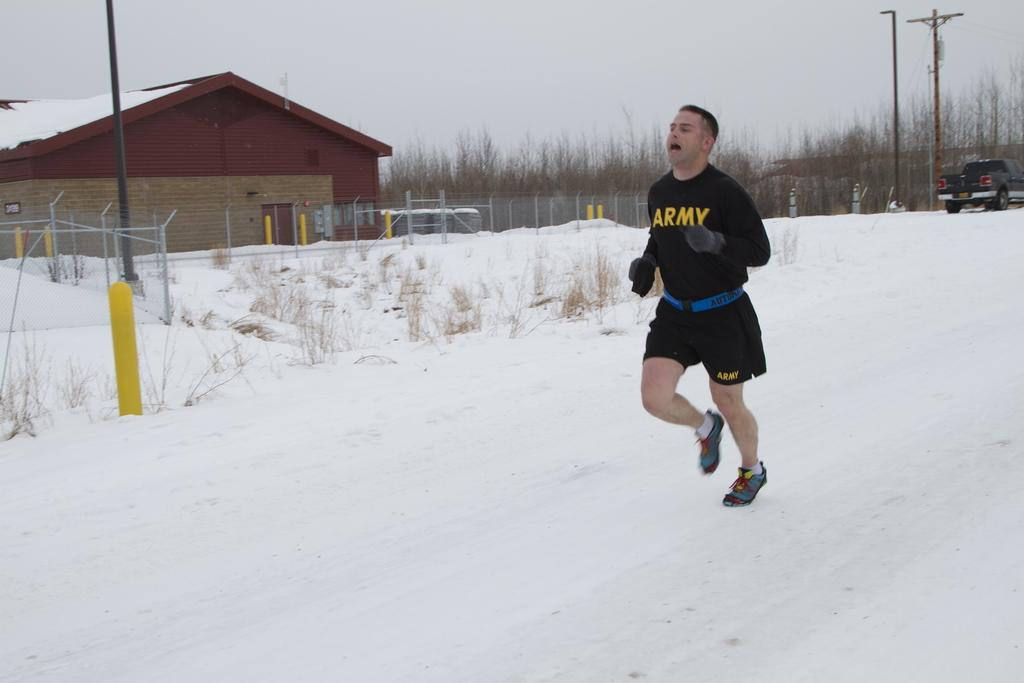<image>
Write a terse but informative summary of the picture. a person running with an army shirt on 